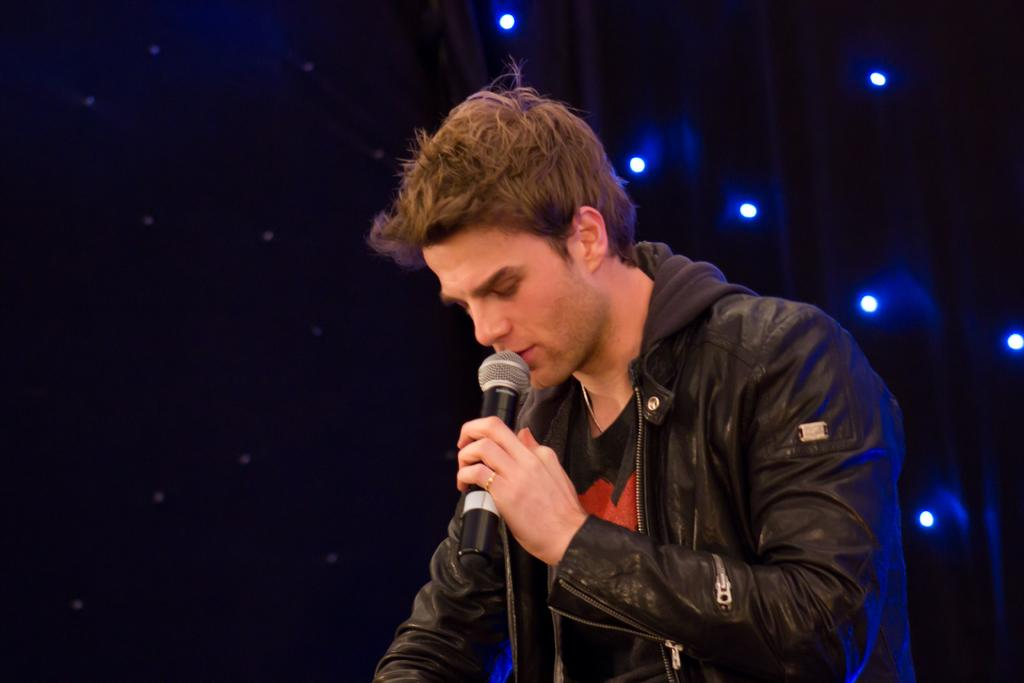Who is the main subject in the image? There is a man in the image. What is the man holding in the image? The man is holding a microphone. What can be seen behind the man in the image? There are lights visible behind the man. How would you describe the overall lighting in the image? The background of the image is dark. What type of cake is being argued about in the wilderness in the image? There is no cake or argument present in the image, and the image does not depict a wilderness setting. 